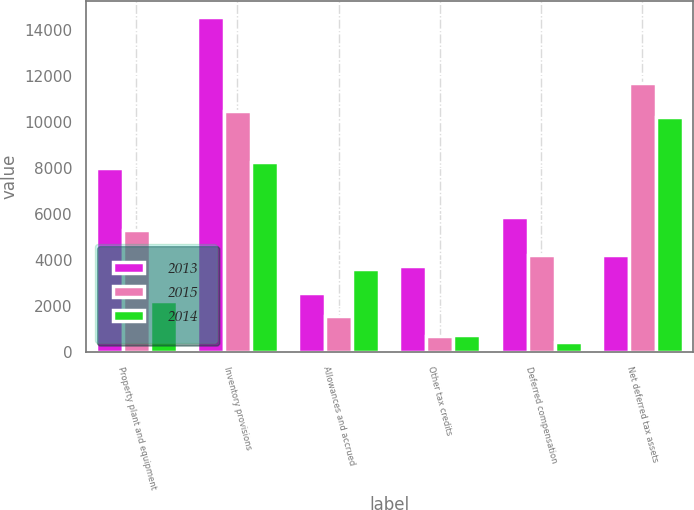Convert chart. <chart><loc_0><loc_0><loc_500><loc_500><stacked_bar_chart><ecel><fcel>Property plant and equipment<fcel>Inventory provisions<fcel>Allowances and accrued<fcel>Other tax credits<fcel>Deferred compensation<fcel>Net deferred tax assets<nl><fcel>2013<fcel>8031<fcel>14566<fcel>2590<fcel>3763<fcel>5891<fcel>4218<nl><fcel>2015<fcel>5310<fcel>10497<fcel>1570<fcel>726<fcel>4218<fcel>11701<nl><fcel>2014<fcel>2230<fcel>8261<fcel>3634<fcel>769<fcel>434<fcel>10229<nl></chart> 